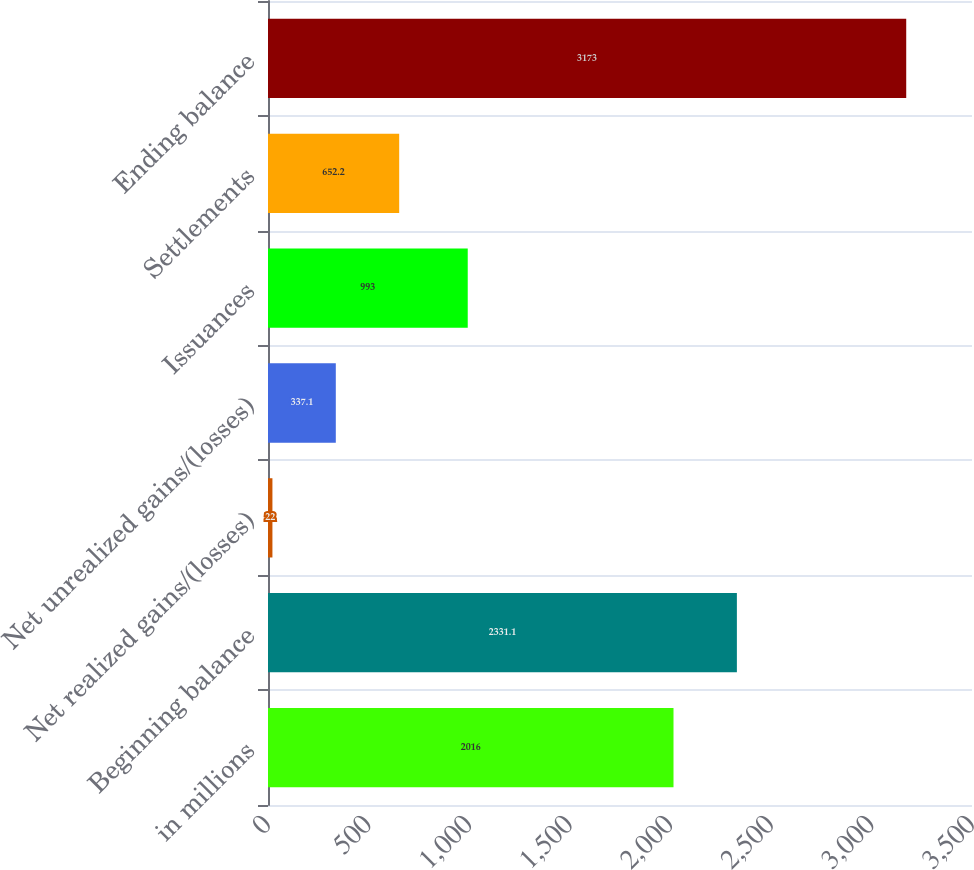Convert chart to OTSL. <chart><loc_0><loc_0><loc_500><loc_500><bar_chart><fcel>in millions<fcel>Beginning balance<fcel>Net realized gains/(losses)<fcel>Net unrealized gains/(losses)<fcel>Issuances<fcel>Settlements<fcel>Ending balance<nl><fcel>2016<fcel>2331.1<fcel>22<fcel>337.1<fcel>993<fcel>652.2<fcel>3173<nl></chart> 